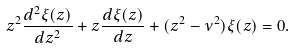Convert formula to latex. <formula><loc_0><loc_0><loc_500><loc_500>z ^ { 2 } \frac { d ^ { 2 } \xi ( z ) } { d z ^ { 2 } } + z \frac { d \xi ( z ) } { d z } + ( z ^ { 2 } - \nu ^ { 2 } ) \xi ( z ) = 0 .</formula> 